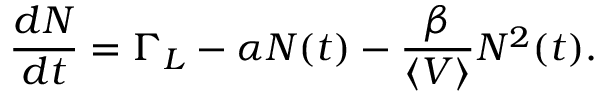<formula> <loc_0><loc_0><loc_500><loc_500>\frac { d N } { d t } = \Gamma _ { L } - \alpha N ( t ) - \frac { \beta } { \left \langle V \right \rangle } N ^ { 2 } ( t ) .</formula> 